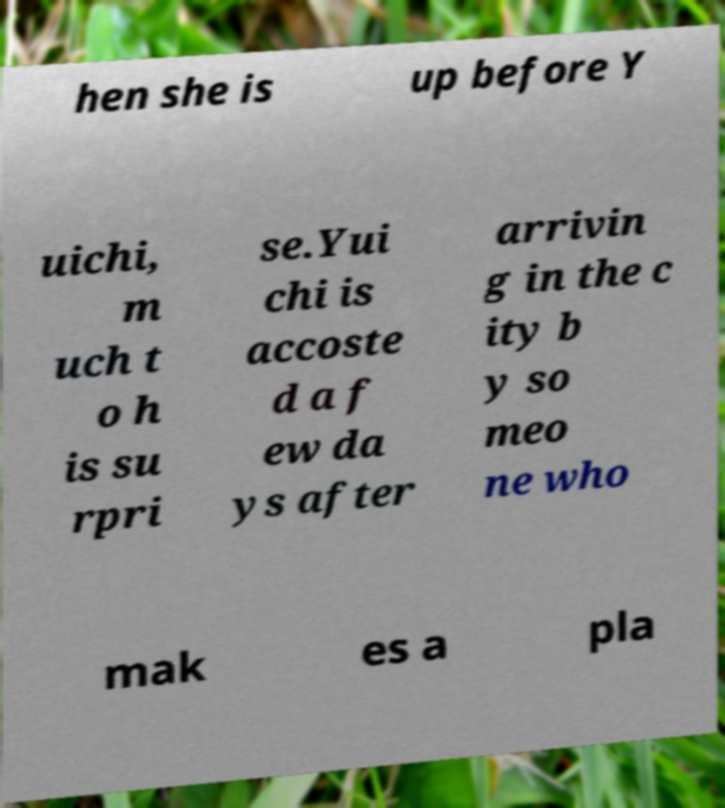There's text embedded in this image that I need extracted. Can you transcribe it verbatim? hen she is up before Y uichi, m uch t o h is su rpri se.Yui chi is accoste d a f ew da ys after arrivin g in the c ity b y so meo ne who mak es a pla 